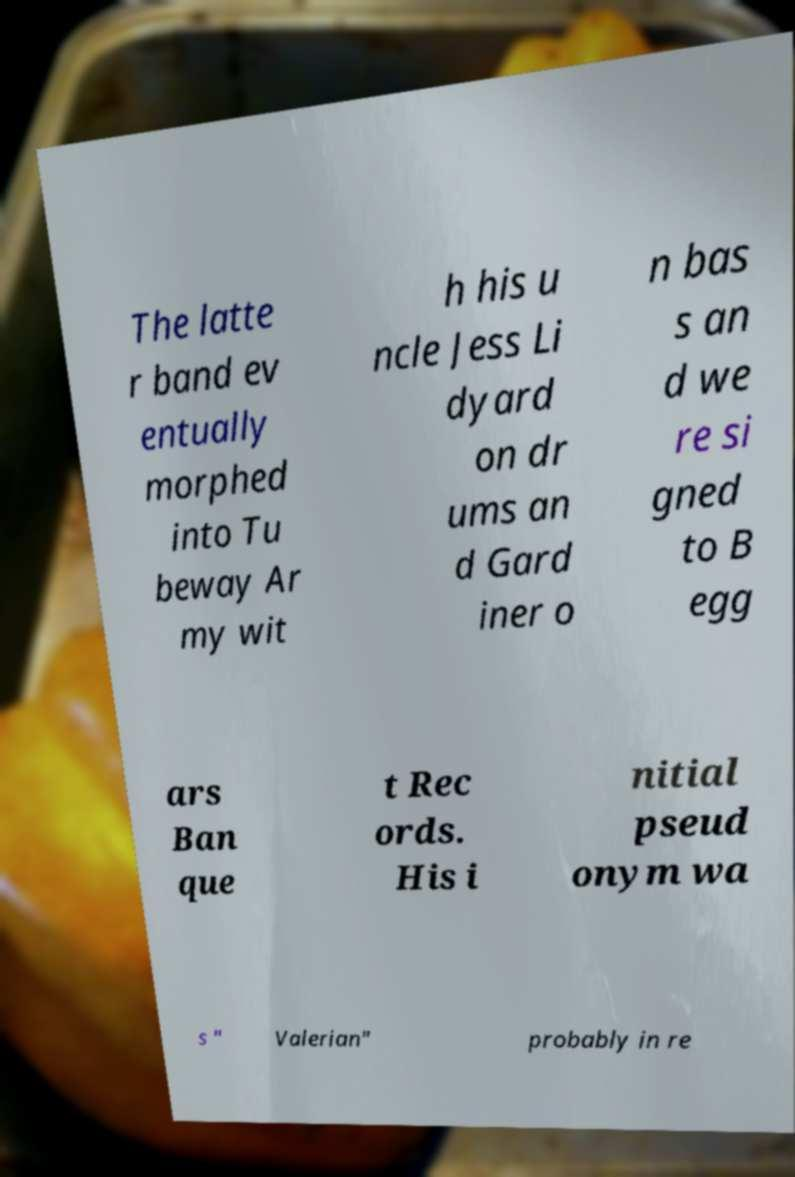For documentation purposes, I need the text within this image transcribed. Could you provide that? The latte r band ev entually morphed into Tu beway Ar my wit h his u ncle Jess Li dyard on dr ums an d Gard iner o n bas s an d we re si gned to B egg ars Ban que t Rec ords. His i nitial pseud onym wa s " Valerian" probably in re 